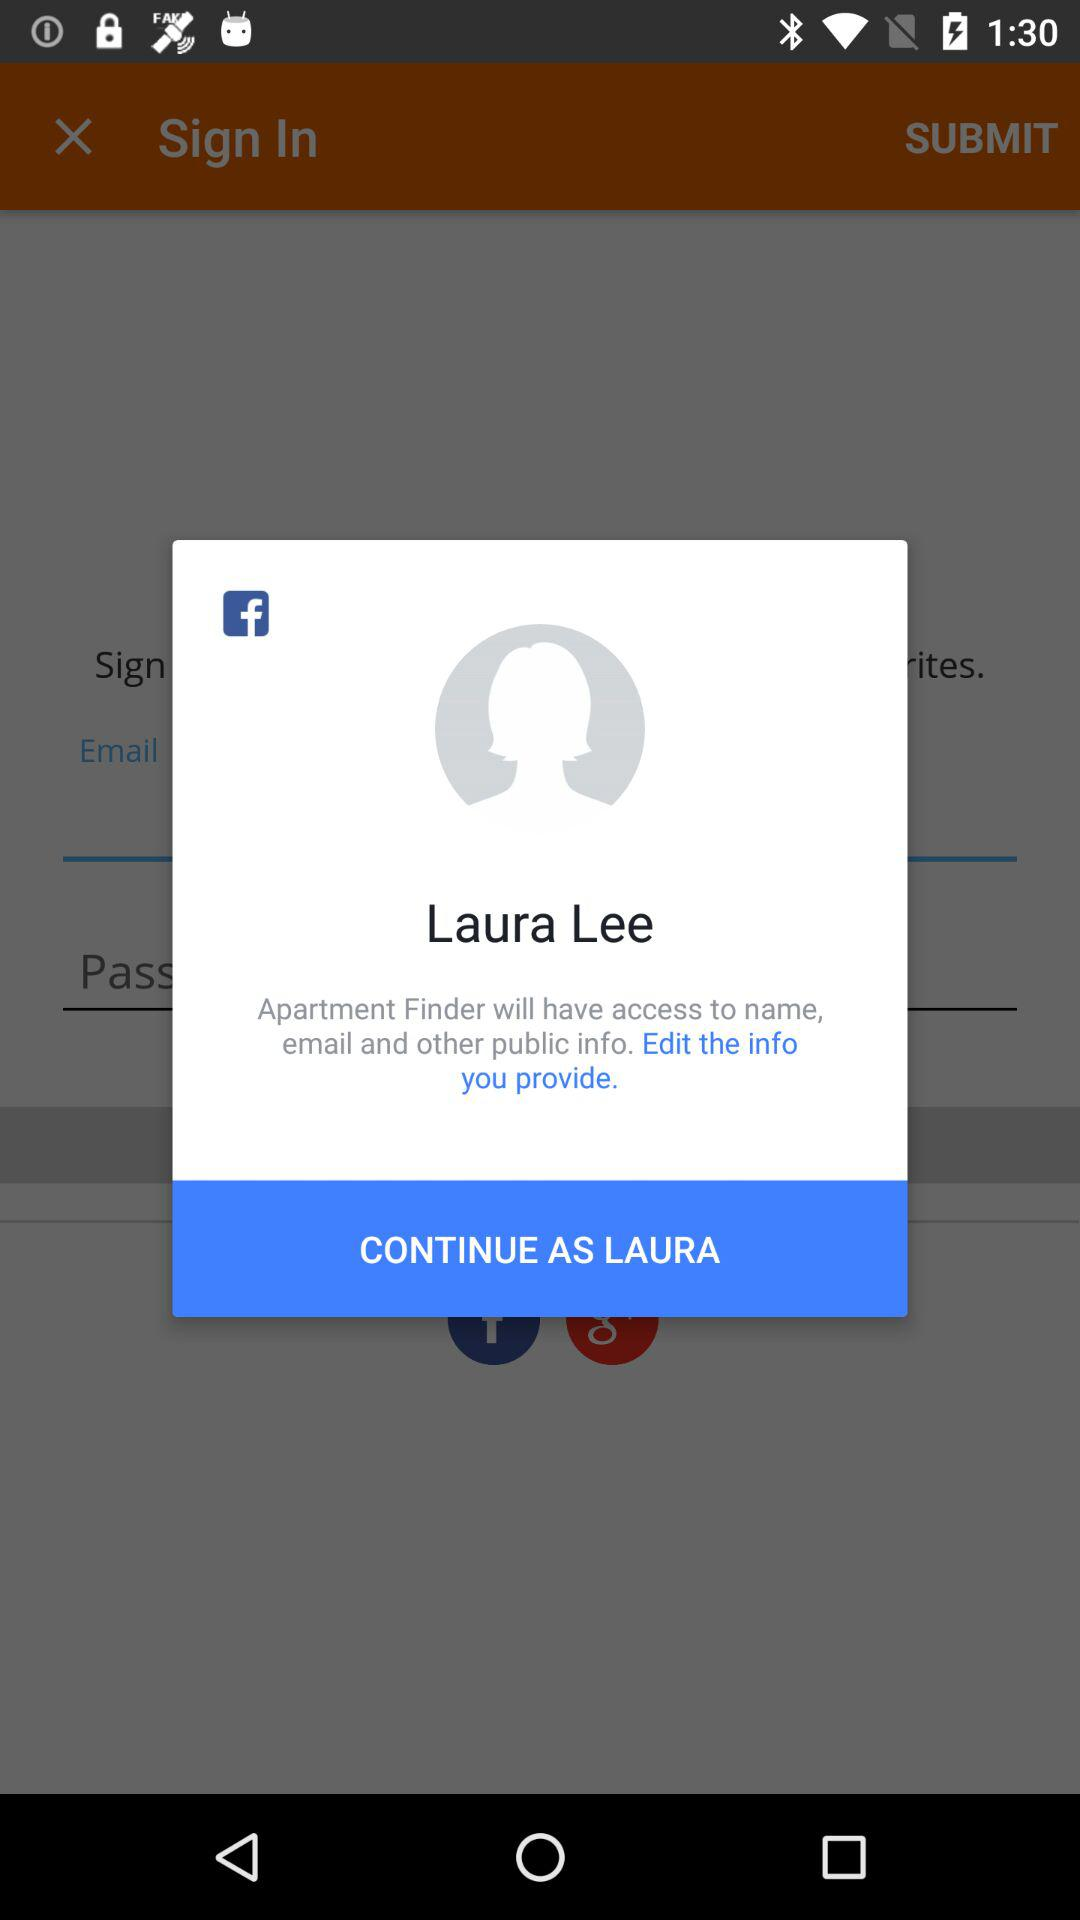What is the name of the application? The application names are "Facebook" and "Apartment Finder". 